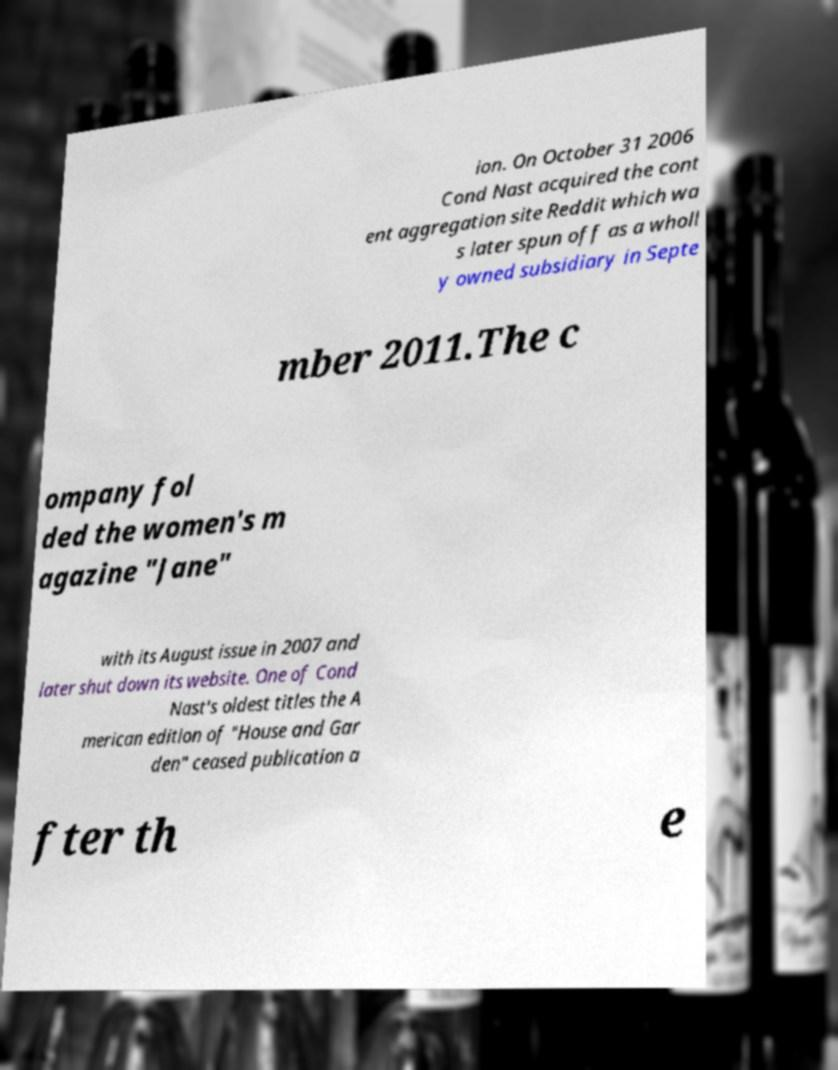What messages or text are displayed in this image? I need them in a readable, typed format. ion. On October 31 2006 Cond Nast acquired the cont ent aggregation site Reddit which wa s later spun off as a wholl y owned subsidiary in Septe mber 2011.The c ompany fol ded the women's m agazine "Jane" with its August issue in 2007 and later shut down its website. One of Cond Nast's oldest titles the A merican edition of "House and Gar den" ceased publication a fter th e 